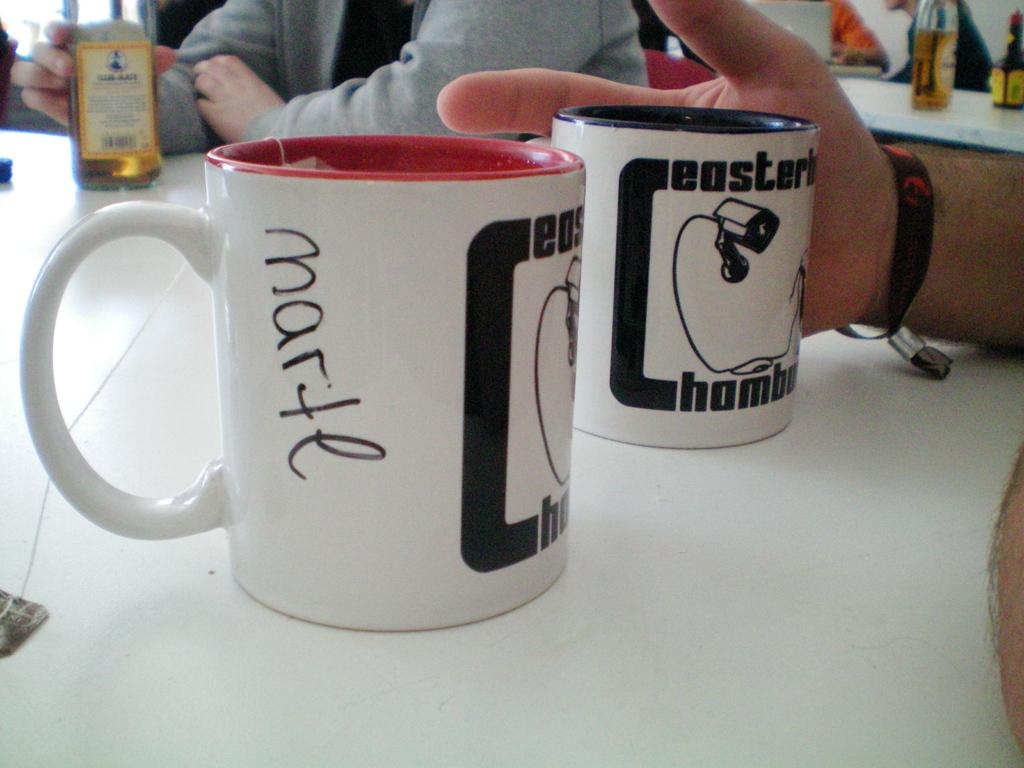Who's coffee cup is it?
Ensure brevity in your answer.  Marte. What does the black text near the camera say?
Your response must be concise. Marte. 